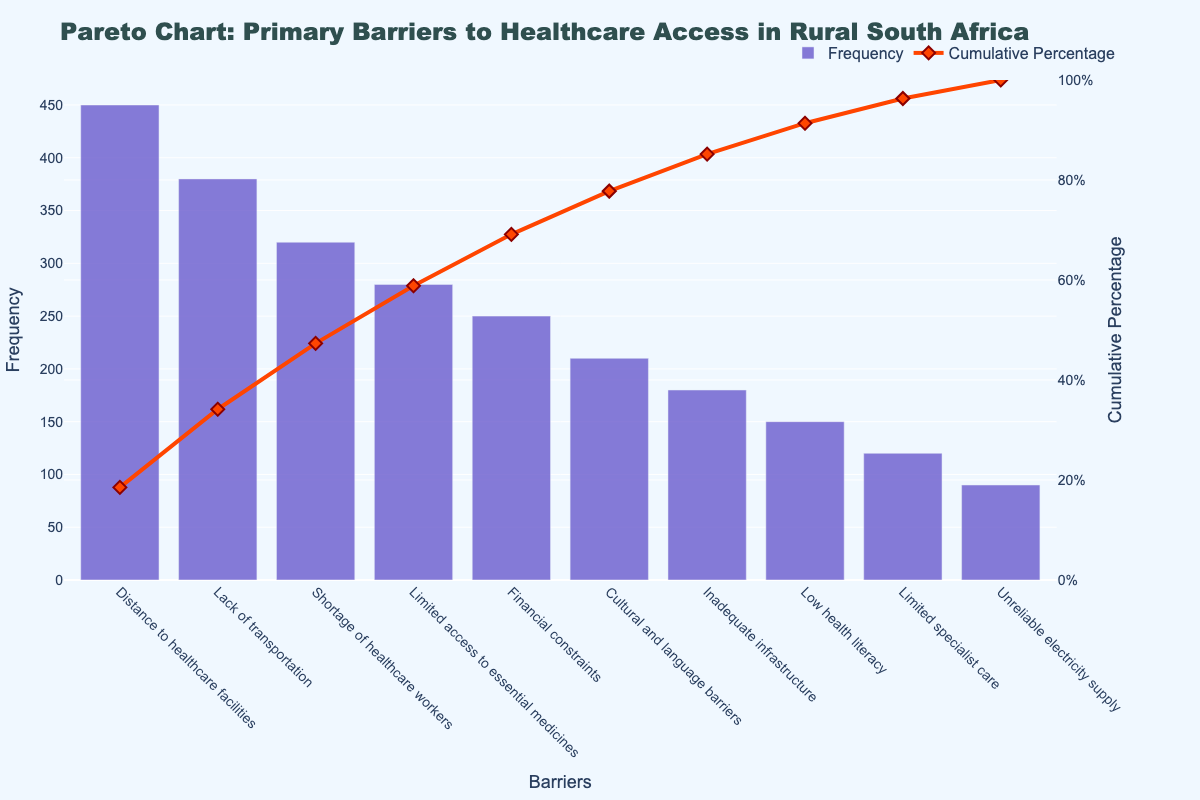What is the title of the chart? The title of the chart is usually the first thing written at the top and it summarizes the main topic of the chart.
Answer: Pareto Chart: Primary Barriers to Healthcare Access in Rural South Africa What barrier has the highest frequency? The barrier with the highest frequency will have the tallest bar in the chart.
Answer: Distance to healthcare facilities How many barriers are identified in the chart? Count the number of unique bars representing different barriers in the chart.
Answer: 10 What is the cumulative percentage for the barrier "Shortage of healthcare workers"? Locate the point on the cumulative percentage line corresponding to "Shortage of healthcare workers" and read the value.
Answer: 57.5% What is the cumulative percentage after adding the top three barriers? Add the frequency of the top three barriers, then find their cumulative percentage.
Answer: 73.5% Which barrier has the lowest frequency? The barrier with the shortest bar on the chart represents the lowest frequency.
Answer: Unreliable electricity supply How many barriers have a frequency higher than 200? Count the number of bars that exceed the 200 mark on the frequency axis.
Answer: 6 What is the frequency difference between the top barrier and the bottom barrier? Subtract the frequency of "Unreliable electricity supply" from "Distance to healthcare facilities."
Answer: 360 Which barriers cumulatively account for just over 50% of the total frequency? Find the barriers whose cumulative percentage just exceeds 50% by tracking the cumulative percentage line.
Answer: Distance to healthcare facilities, Lack of transportation, Shortage of healthcare workers How does the barrier "Financial constraints" compare in frequency to "Cultural and language barriers"? Compare the heights of the bars for the two barriers to see which one is taller.
Answer: Financial constraints has a higher frequency 